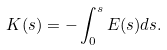Convert formula to latex. <formula><loc_0><loc_0><loc_500><loc_500>K ( s ) = - \int _ { 0 } ^ { s } E ( s ) d s .</formula> 